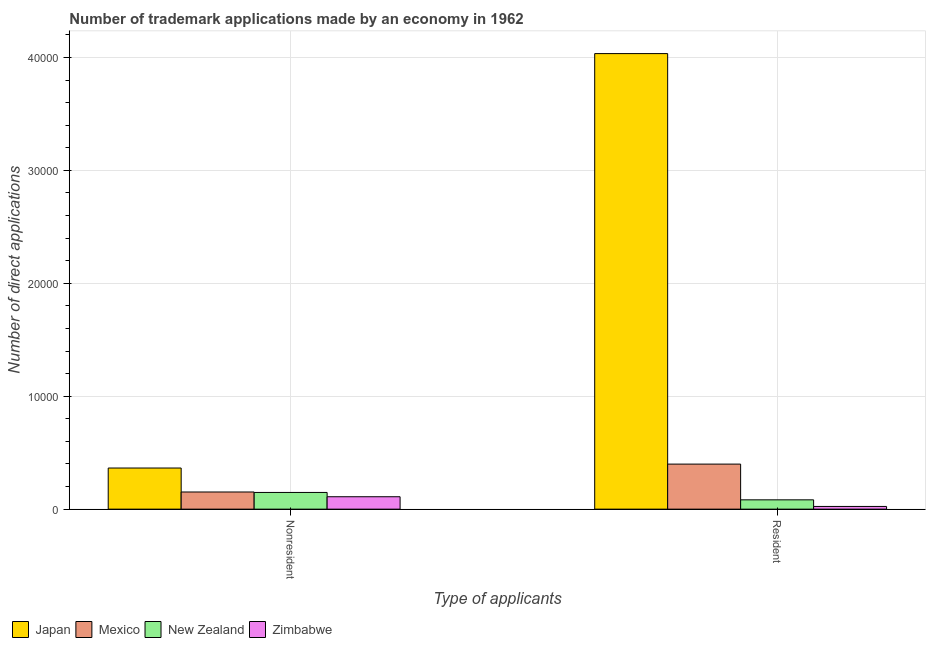How many different coloured bars are there?
Provide a short and direct response. 4. How many groups of bars are there?
Provide a short and direct response. 2. Are the number of bars on each tick of the X-axis equal?
Your response must be concise. Yes. How many bars are there on the 2nd tick from the left?
Provide a succinct answer. 4. How many bars are there on the 1st tick from the right?
Give a very brief answer. 4. What is the label of the 2nd group of bars from the left?
Give a very brief answer. Resident. What is the number of trademark applications made by residents in Japan?
Your response must be concise. 4.03e+04. Across all countries, what is the maximum number of trademark applications made by non residents?
Offer a very short reply. 3642. Across all countries, what is the minimum number of trademark applications made by residents?
Your answer should be compact. 239. In which country was the number of trademark applications made by non residents minimum?
Your answer should be compact. Zimbabwe. What is the total number of trademark applications made by residents in the graph?
Your response must be concise. 4.54e+04. What is the difference between the number of trademark applications made by residents in New Zealand and that in Mexico?
Offer a very short reply. -3164. What is the difference between the number of trademark applications made by non residents in Zimbabwe and the number of trademark applications made by residents in New Zealand?
Offer a very short reply. 274. What is the average number of trademark applications made by non residents per country?
Provide a succinct answer. 1935. What is the difference between the number of trademark applications made by residents and number of trademark applications made by non residents in Zimbabwe?
Make the answer very short. -860. What is the ratio of the number of trademark applications made by non residents in Mexico to that in Zimbabwe?
Ensure brevity in your answer.  1.38. In how many countries, is the number of trademark applications made by non residents greater than the average number of trademark applications made by non residents taken over all countries?
Offer a very short reply. 1. What does the 2nd bar from the left in Nonresident represents?
Your answer should be very brief. Mexico. What does the 1st bar from the right in Resident represents?
Your response must be concise. Zimbabwe. How many bars are there?
Give a very brief answer. 8. Are all the bars in the graph horizontal?
Provide a succinct answer. No. What is the difference between two consecutive major ticks on the Y-axis?
Make the answer very short. 10000. Are the values on the major ticks of Y-axis written in scientific E-notation?
Your response must be concise. No. Does the graph contain any zero values?
Provide a succinct answer. No. Does the graph contain grids?
Your response must be concise. Yes. What is the title of the graph?
Give a very brief answer. Number of trademark applications made by an economy in 1962. Does "Dominica" appear as one of the legend labels in the graph?
Provide a succinct answer. No. What is the label or title of the X-axis?
Offer a terse response. Type of applicants. What is the label or title of the Y-axis?
Your answer should be very brief. Number of direct applications. What is the Number of direct applications in Japan in Nonresident?
Provide a short and direct response. 3642. What is the Number of direct applications in Mexico in Nonresident?
Offer a very short reply. 1520. What is the Number of direct applications in New Zealand in Nonresident?
Your answer should be compact. 1479. What is the Number of direct applications in Zimbabwe in Nonresident?
Your answer should be compact. 1099. What is the Number of direct applications of Japan in Resident?
Give a very brief answer. 4.03e+04. What is the Number of direct applications in Mexico in Resident?
Offer a very short reply. 3989. What is the Number of direct applications of New Zealand in Resident?
Your answer should be very brief. 825. What is the Number of direct applications of Zimbabwe in Resident?
Make the answer very short. 239. Across all Type of applicants, what is the maximum Number of direct applications in Japan?
Your answer should be very brief. 4.03e+04. Across all Type of applicants, what is the maximum Number of direct applications in Mexico?
Your answer should be compact. 3989. Across all Type of applicants, what is the maximum Number of direct applications in New Zealand?
Make the answer very short. 1479. Across all Type of applicants, what is the maximum Number of direct applications of Zimbabwe?
Your answer should be compact. 1099. Across all Type of applicants, what is the minimum Number of direct applications of Japan?
Offer a terse response. 3642. Across all Type of applicants, what is the minimum Number of direct applications in Mexico?
Your answer should be very brief. 1520. Across all Type of applicants, what is the minimum Number of direct applications in New Zealand?
Provide a succinct answer. 825. Across all Type of applicants, what is the minimum Number of direct applications in Zimbabwe?
Provide a succinct answer. 239. What is the total Number of direct applications of Japan in the graph?
Provide a short and direct response. 4.40e+04. What is the total Number of direct applications of Mexico in the graph?
Your answer should be compact. 5509. What is the total Number of direct applications in New Zealand in the graph?
Keep it short and to the point. 2304. What is the total Number of direct applications of Zimbabwe in the graph?
Your response must be concise. 1338. What is the difference between the Number of direct applications of Japan in Nonresident and that in Resident?
Make the answer very short. -3.67e+04. What is the difference between the Number of direct applications of Mexico in Nonresident and that in Resident?
Your answer should be compact. -2469. What is the difference between the Number of direct applications in New Zealand in Nonresident and that in Resident?
Your answer should be very brief. 654. What is the difference between the Number of direct applications of Zimbabwe in Nonresident and that in Resident?
Provide a succinct answer. 860. What is the difference between the Number of direct applications in Japan in Nonresident and the Number of direct applications in Mexico in Resident?
Ensure brevity in your answer.  -347. What is the difference between the Number of direct applications in Japan in Nonresident and the Number of direct applications in New Zealand in Resident?
Offer a terse response. 2817. What is the difference between the Number of direct applications of Japan in Nonresident and the Number of direct applications of Zimbabwe in Resident?
Give a very brief answer. 3403. What is the difference between the Number of direct applications in Mexico in Nonresident and the Number of direct applications in New Zealand in Resident?
Provide a succinct answer. 695. What is the difference between the Number of direct applications of Mexico in Nonresident and the Number of direct applications of Zimbabwe in Resident?
Your answer should be compact. 1281. What is the difference between the Number of direct applications of New Zealand in Nonresident and the Number of direct applications of Zimbabwe in Resident?
Keep it short and to the point. 1240. What is the average Number of direct applications of Japan per Type of applicants?
Your answer should be very brief. 2.20e+04. What is the average Number of direct applications of Mexico per Type of applicants?
Provide a succinct answer. 2754.5. What is the average Number of direct applications of New Zealand per Type of applicants?
Give a very brief answer. 1152. What is the average Number of direct applications in Zimbabwe per Type of applicants?
Your answer should be compact. 669. What is the difference between the Number of direct applications of Japan and Number of direct applications of Mexico in Nonresident?
Keep it short and to the point. 2122. What is the difference between the Number of direct applications of Japan and Number of direct applications of New Zealand in Nonresident?
Ensure brevity in your answer.  2163. What is the difference between the Number of direct applications in Japan and Number of direct applications in Zimbabwe in Nonresident?
Offer a very short reply. 2543. What is the difference between the Number of direct applications of Mexico and Number of direct applications of Zimbabwe in Nonresident?
Offer a very short reply. 421. What is the difference between the Number of direct applications in New Zealand and Number of direct applications in Zimbabwe in Nonresident?
Offer a terse response. 380. What is the difference between the Number of direct applications in Japan and Number of direct applications in Mexico in Resident?
Keep it short and to the point. 3.64e+04. What is the difference between the Number of direct applications of Japan and Number of direct applications of New Zealand in Resident?
Ensure brevity in your answer.  3.95e+04. What is the difference between the Number of direct applications in Japan and Number of direct applications in Zimbabwe in Resident?
Your response must be concise. 4.01e+04. What is the difference between the Number of direct applications of Mexico and Number of direct applications of New Zealand in Resident?
Offer a terse response. 3164. What is the difference between the Number of direct applications in Mexico and Number of direct applications in Zimbabwe in Resident?
Your answer should be compact. 3750. What is the difference between the Number of direct applications of New Zealand and Number of direct applications of Zimbabwe in Resident?
Give a very brief answer. 586. What is the ratio of the Number of direct applications in Japan in Nonresident to that in Resident?
Offer a very short reply. 0.09. What is the ratio of the Number of direct applications in Mexico in Nonresident to that in Resident?
Your answer should be compact. 0.38. What is the ratio of the Number of direct applications of New Zealand in Nonresident to that in Resident?
Your answer should be compact. 1.79. What is the ratio of the Number of direct applications in Zimbabwe in Nonresident to that in Resident?
Offer a terse response. 4.6. What is the difference between the highest and the second highest Number of direct applications in Japan?
Make the answer very short. 3.67e+04. What is the difference between the highest and the second highest Number of direct applications in Mexico?
Give a very brief answer. 2469. What is the difference between the highest and the second highest Number of direct applications of New Zealand?
Give a very brief answer. 654. What is the difference between the highest and the second highest Number of direct applications of Zimbabwe?
Provide a short and direct response. 860. What is the difference between the highest and the lowest Number of direct applications of Japan?
Your response must be concise. 3.67e+04. What is the difference between the highest and the lowest Number of direct applications in Mexico?
Give a very brief answer. 2469. What is the difference between the highest and the lowest Number of direct applications of New Zealand?
Your answer should be compact. 654. What is the difference between the highest and the lowest Number of direct applications in Zimbabwe?
Offer a terse response. 860. 